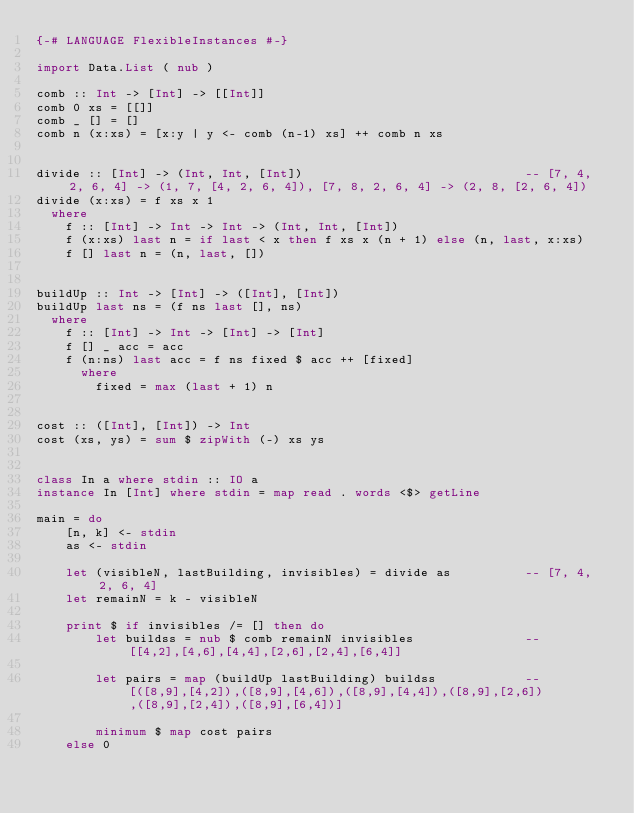<code> <loc_0><loc_0><loc_500><loc_500><_Haskell_>{-# LANGUAGE FlexibleInstances #-}

import Data.List ( nub )

comb :: Int -> [Int] -> [[Int]]
comb 0 xs = [[]]
comb _ [] = []
comb n (x:xs) = [x:y | y <- comb (n-1) xs] ++ comb n xs


divide :: [Int] -> (Int, Int, [Int])                              -- [7, 4, 2, 6, 4] -> (1, 7, [4, 2, 6, 4]), [7, 8, 2, 6, 4] -> (2, 8, [2, 6, 4])
divide (x:xs) = f xs x 1
  where
    f :: [Int] -> Int -> Int -> (Int, Int, [Int])
    f (x:xs) last n = if last < x then f xs x (n + 1) else (n, last, x:xs)
    f [] last n = (n, last, [])


buildUp :: Int -> [Int] -> ([Int], [Int])
buildUp last ns = (f ns last [], ns)
  where
    f :: [Int] -> Int -> [Int] -> [Int]
    f [] _ acc = acc
    f (n:ns) last acc = f ns fixed $ acc ++ [fixed]
      where
        fixed = max (last + 1) n


cost :: ([Int], [Int]) -> Int
cost (xs, ys) = sum $ zipWith (-) xs ys


class In a where stdin :: IO a
instance In [Int] where stdin = map read . words <$> getLine

main = do
    [n, k] <- stdin
    as <- stdin

    let (visibleN, lastBuilding, invisibles) = divide as          -- [7, 4, 2, 6, 4]
    let remainN = k - visibleN

    print $ if invisibles /= [] then do
        let buildss = nub $ comb remainN invisibles               -- [[4,2],[4,6],[4,4],[2,6],[2,4],[6,4]]

        let pairs = map (buildUp lastBuilding) buildss            -- [([8,9],[4,2]),([8,9],[4,6]),([8,9],[4,4]),([8,9],[2,6]),([8,9],[2,4]),([8,9],[6,4])]

        minimum $ map cost pairs
    else 0
</code> 